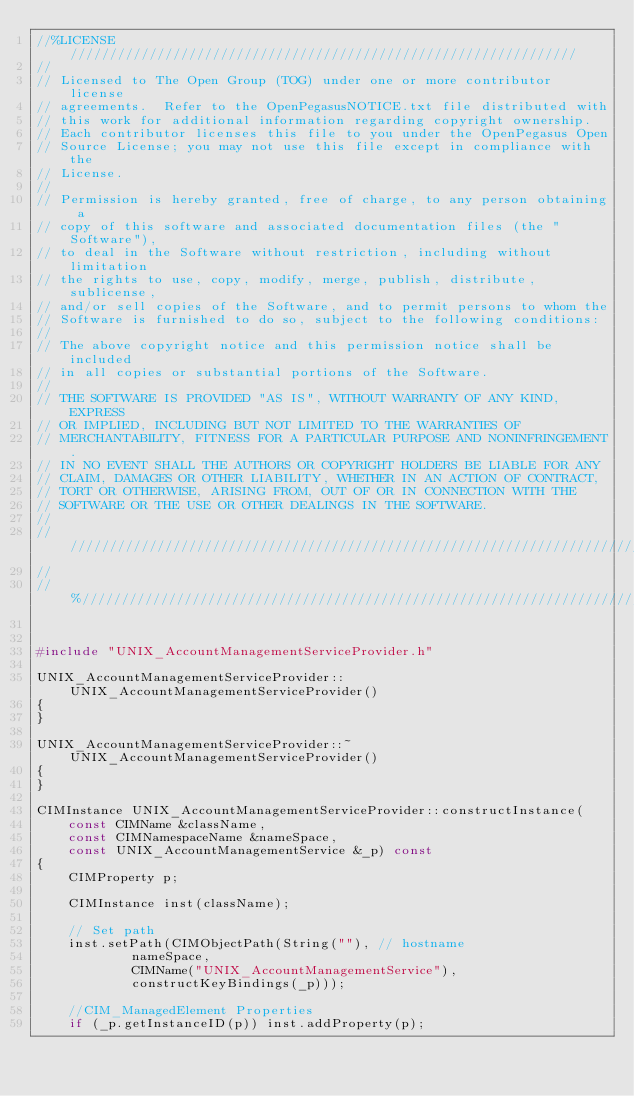Convert code to text. <code><loc_0><loc_0><loc_500><loc_500><_C++_>//%LICENSE////////////////////////////////////////////////////////////////
//
// Licensed to The Open Group (TOG) under one or more contributor license
// agreements.  Refer to the OpenPegasusNOTICE.txt file distributed with
// this work for additional information regarding copyright ownership.
// Each contributor licenses this file to you under the OpenPegasus Open
// Source License; you may not use this file except in compliance with the
// License.
//
// Permission is hereby granted, free of charge, to any person obtaining a
// copy of this software and associated documentation files (the "Software"),
// to deal in the Software without restriction, including without limitation
// the rights to use, copy, modify, merge, publish, distribute, sublicense,
// and/or sell copies of the Software, and to permit persons to whom the
// Software is furnished to do so, subject to the following conditions:
//
// The above copyright notice and this permission notice shall be included
// in all copies or substantial portions of the Software.
//
// THE SOFTWARE IS PROVIDED "AS IS", WITHOUT WARRANTY OF ANY KIND, EXPRESS
// OR IMPLIED, INCLUDING BUT NOT LIMITED TO THE WARRANTIES OF
// MERCHANTABILITY, FITNESS FOR A PARTICULAR PURPOSE AND NONINFRINGEMENT.
// IN NO EVENT SHALL THE AUTHORS OR COPYRIGHT HOLDERS BE LIABLE FOR ANY
// CLAIM, DAMAGES OR OTHER LIABILITY, WHETHER IN AN ACTION OF CONTRACT,
// TORT OR OTHERWISE, ARISING FROM, OUT OF OR IN CONNECTION WITH THE
// SOFTWARE OR THE USE OR OTHER DEALINGS IN THE SOFTWARE.
//
//////////////////////////////////////////////////////////////////////////
//
//%/////////////////////////////////////////////////////////////////////////


#include "UNIX_AccountManagementServiceProvider.h"

UNIX_AccountManagementServiceProvider::UNIX_AccountManagementServiceProvider()
{
}

UNIX_AccountManagementServiceProvider::~UNIX_AccountManagementServiceProvider()
{
}

CIMInstance UNIX_AccountManagementServiceProvider::constructInstance(
	const CIMName &className,
	const CIMNamespaceName &nameSpace,
	const UNIX_AccountManagementService &_p) const
{
	CIMProperty p;

	CIMInstance inst(className);

	// Set path
	inst.setPath(CIMObjectPath(String(""), // hostname
			nameSpace,
			CIMName("UNIX_AccountManagementService"),
			constructKeyBindings(_p)));

	//CIM_ManagedElement Properties
	if (_p.getInstanceID(p)) inst.addProperty(p);</code> 